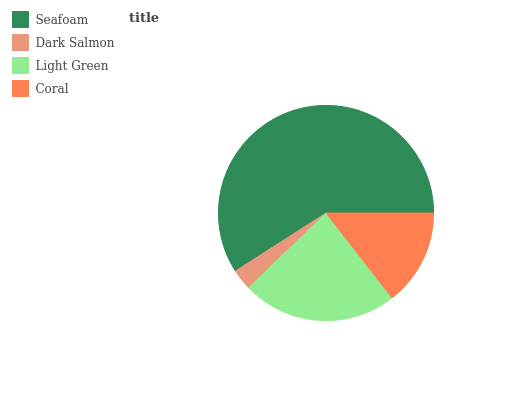Is Dark Salmon the minimum?
Answer yes or no. Yes. Is Seafoam the maximum?
Answer yes or no. Yes. Is Light Green the minimum?
Answer yes or no. No. Is Light Green the maximum?
Answer yes or no. No. Is Light Green greater than Dark Salmon?
Answer yes or no. Yes. Is Dark Salmon less than Light Green?
Answer yes or no. Yes. Is Dark Salmon greater than Light Green?
Answer yes or no. No. Is Light Green less than Dark Salmon?
Answer yes or no. No. Is Light Green the high median?
Answer yes or no. Yes. Is Coral the low median?
Answer yes or no. Yes. Is Coral the high median?
Answer yes or no. No. Is Dark Salmon the low median?
Answer yes or no. No. 